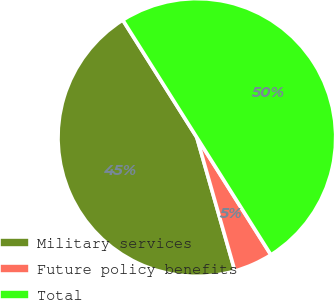Convert chart to OTSL. <chart><loc_0><loc_0><loc_500><loc_500><pie_chart><fcel>Military services<fcel>Future policy benefits<fcel>Total<nl><fcel>45.46%<fcel>4.54%<fcel>50.0%<nl></chart> 